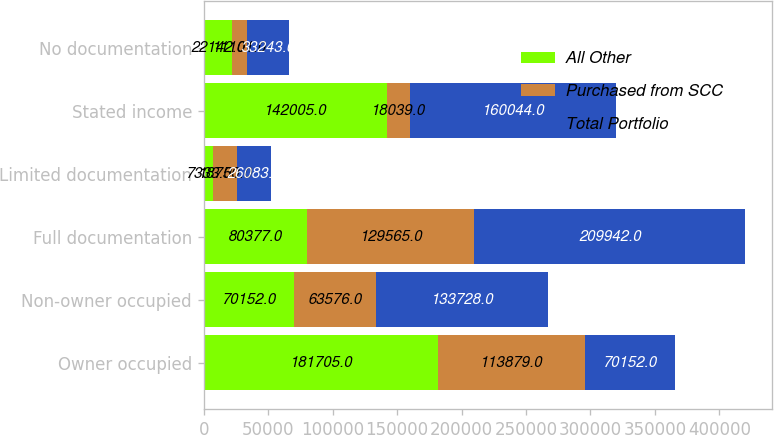Convert chart to OTSL. <chart><loc_0><loc_0><loc_500><loc_500><stacked_bar_chart><ecel><fcel>Owner occupied<fcel>Non-owner occupied<fcel>Full documentation<fcel>Limited documentation<fcel>Stated income<fcel>No documentation<nl><fcel>All Other<fcel>181705<fcel>70152<fcel>80377<fcel>7333<fcel>142005<fcel>22142<nl><fcel>Purchased from SCC<fcel>113879<fcel>63576<fcel>129565<fcel>18750<fcel>18039<fcel>11101<nl><fcel>Total Portfolio<fcel>70152<fcel>133728<fcel>209942<fcel>26083<fcel>160044<fcel>33243<nl></chart> 